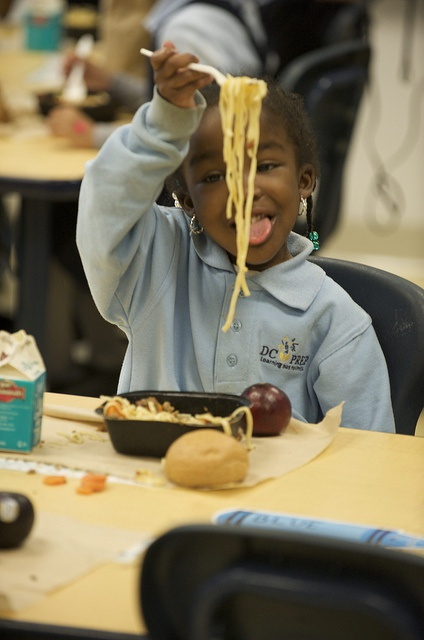Describe the objects in this image and their specific colors. I can see people in black, darkgray, gray, and maroon tones, chair in black and gray tones, dining table in black, khaki, and tan tones, dining table in black, tan, and maroon tones, and chair in black and gray tones in this image. 